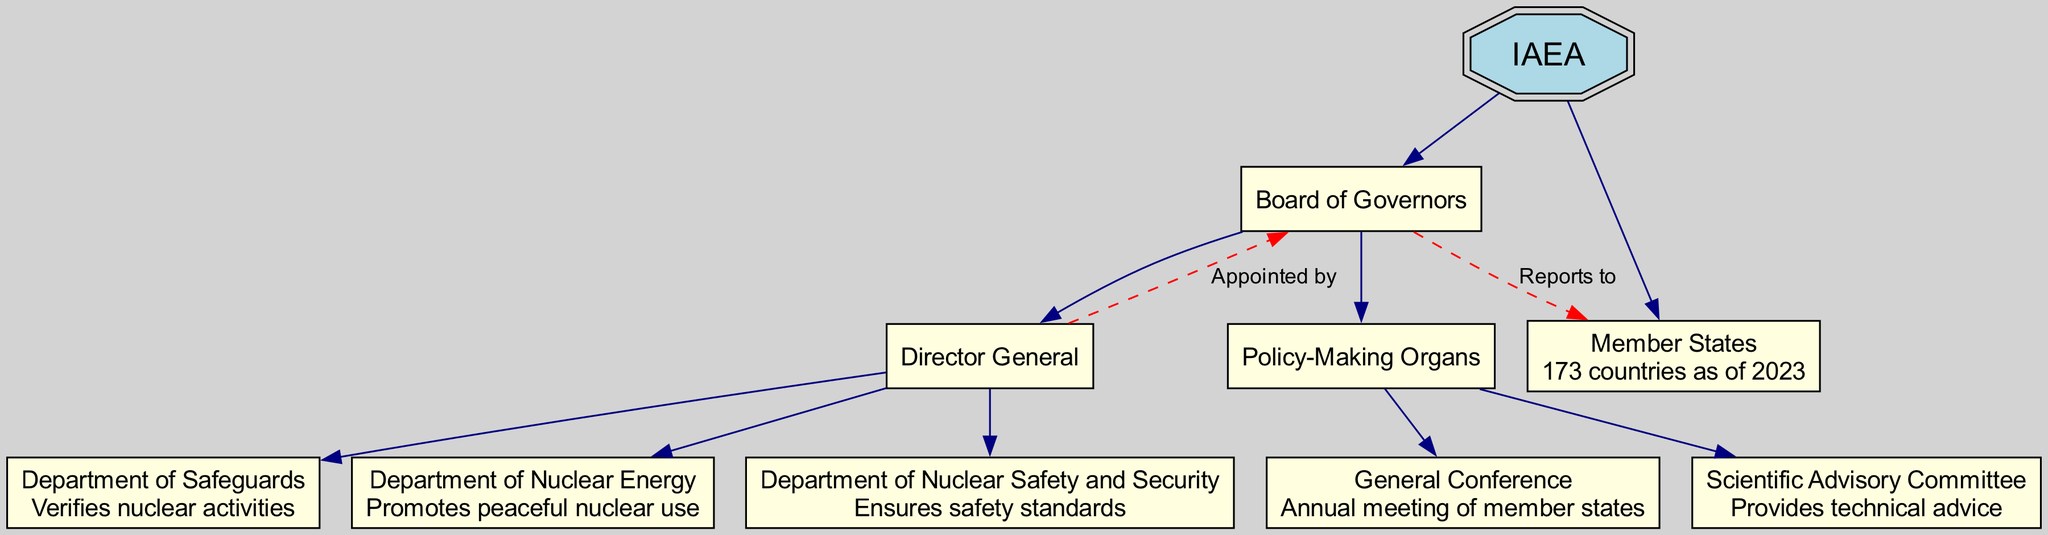What is the role of the Director General? The Director General is at a key point in the hierarchy under the Board of Governors. His role involves overseeing three departments which focus on verifying nuclear activities, promoting peaceful nuclear use, and ensuring safety standards.
Answer: Oversees departments How many member states are part of the IAEA as of 2023? The diagram specifies that there are 173 member states that make up the IAEA. This information is clearly labeled under the Member States node.
Answer: 173 Who does the Director General report to? The diagram indicates that the Director General is appointed by the Board of Governors, showing a direct relationship indicating authority and responsibility.
Answer: Board of Governors What does the Department of Safeguards verify? Referring to the description provided for the Department of Safeguards in the diagram, it specifically indicates that it verifies nuclear activities.
Answer: Verifies nuclear activities How many children does the Board of Governors have? The Board of Governors in the diagram has two primary children nodes: the Director General and the Policy-Making Organs, making it straightforward to count them.
Answer: 2 What does the General Conference do? The General Conference is described in the diagram as an annual meeting of member states, which implies that it facilitates communication and decision-making among IAEA members.
Answer: Annual meeting of member states What is the edge relationship between Member States and Board of Governors? The diagram illustrates that the Board of Governors reports to the Member States, as denoted by the dashed edge connection between these nodes.
Answer: Reports to How many departments are under the Director General? The diagram reveals that the Director General oversees three departments: Department of Safeguards, Department of Nuclear Energy, and Department of Nuclear Safety and Security. Counting these divisions gives the answer.
Answer: 3 What does the Scientific Advisory Committee provide? The description for the Scientific Advisory Committee in the diagram expresses that it provides technical advice, highlighting its supportive role within the IAEA structure.
Answer: Provides technical advice 